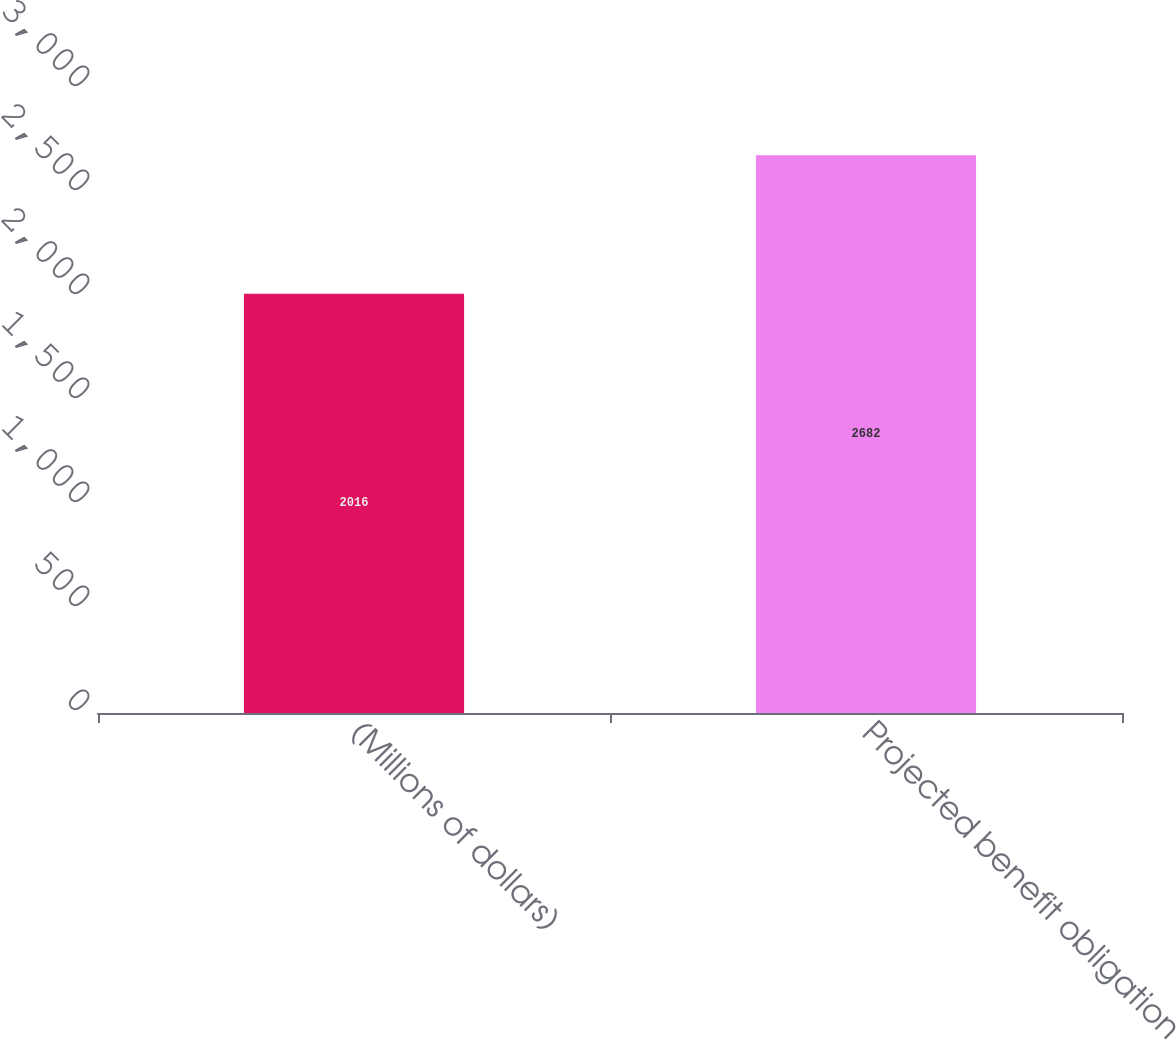Convert chart to OTSL. <chart><loc_0><loc_0><loc_500><loc_500><bar_chart><fcel>(Millions of dollars)<fcel>Projected benefit obligation<nl><fcel>2016<fcel>2682<nl></chart> 